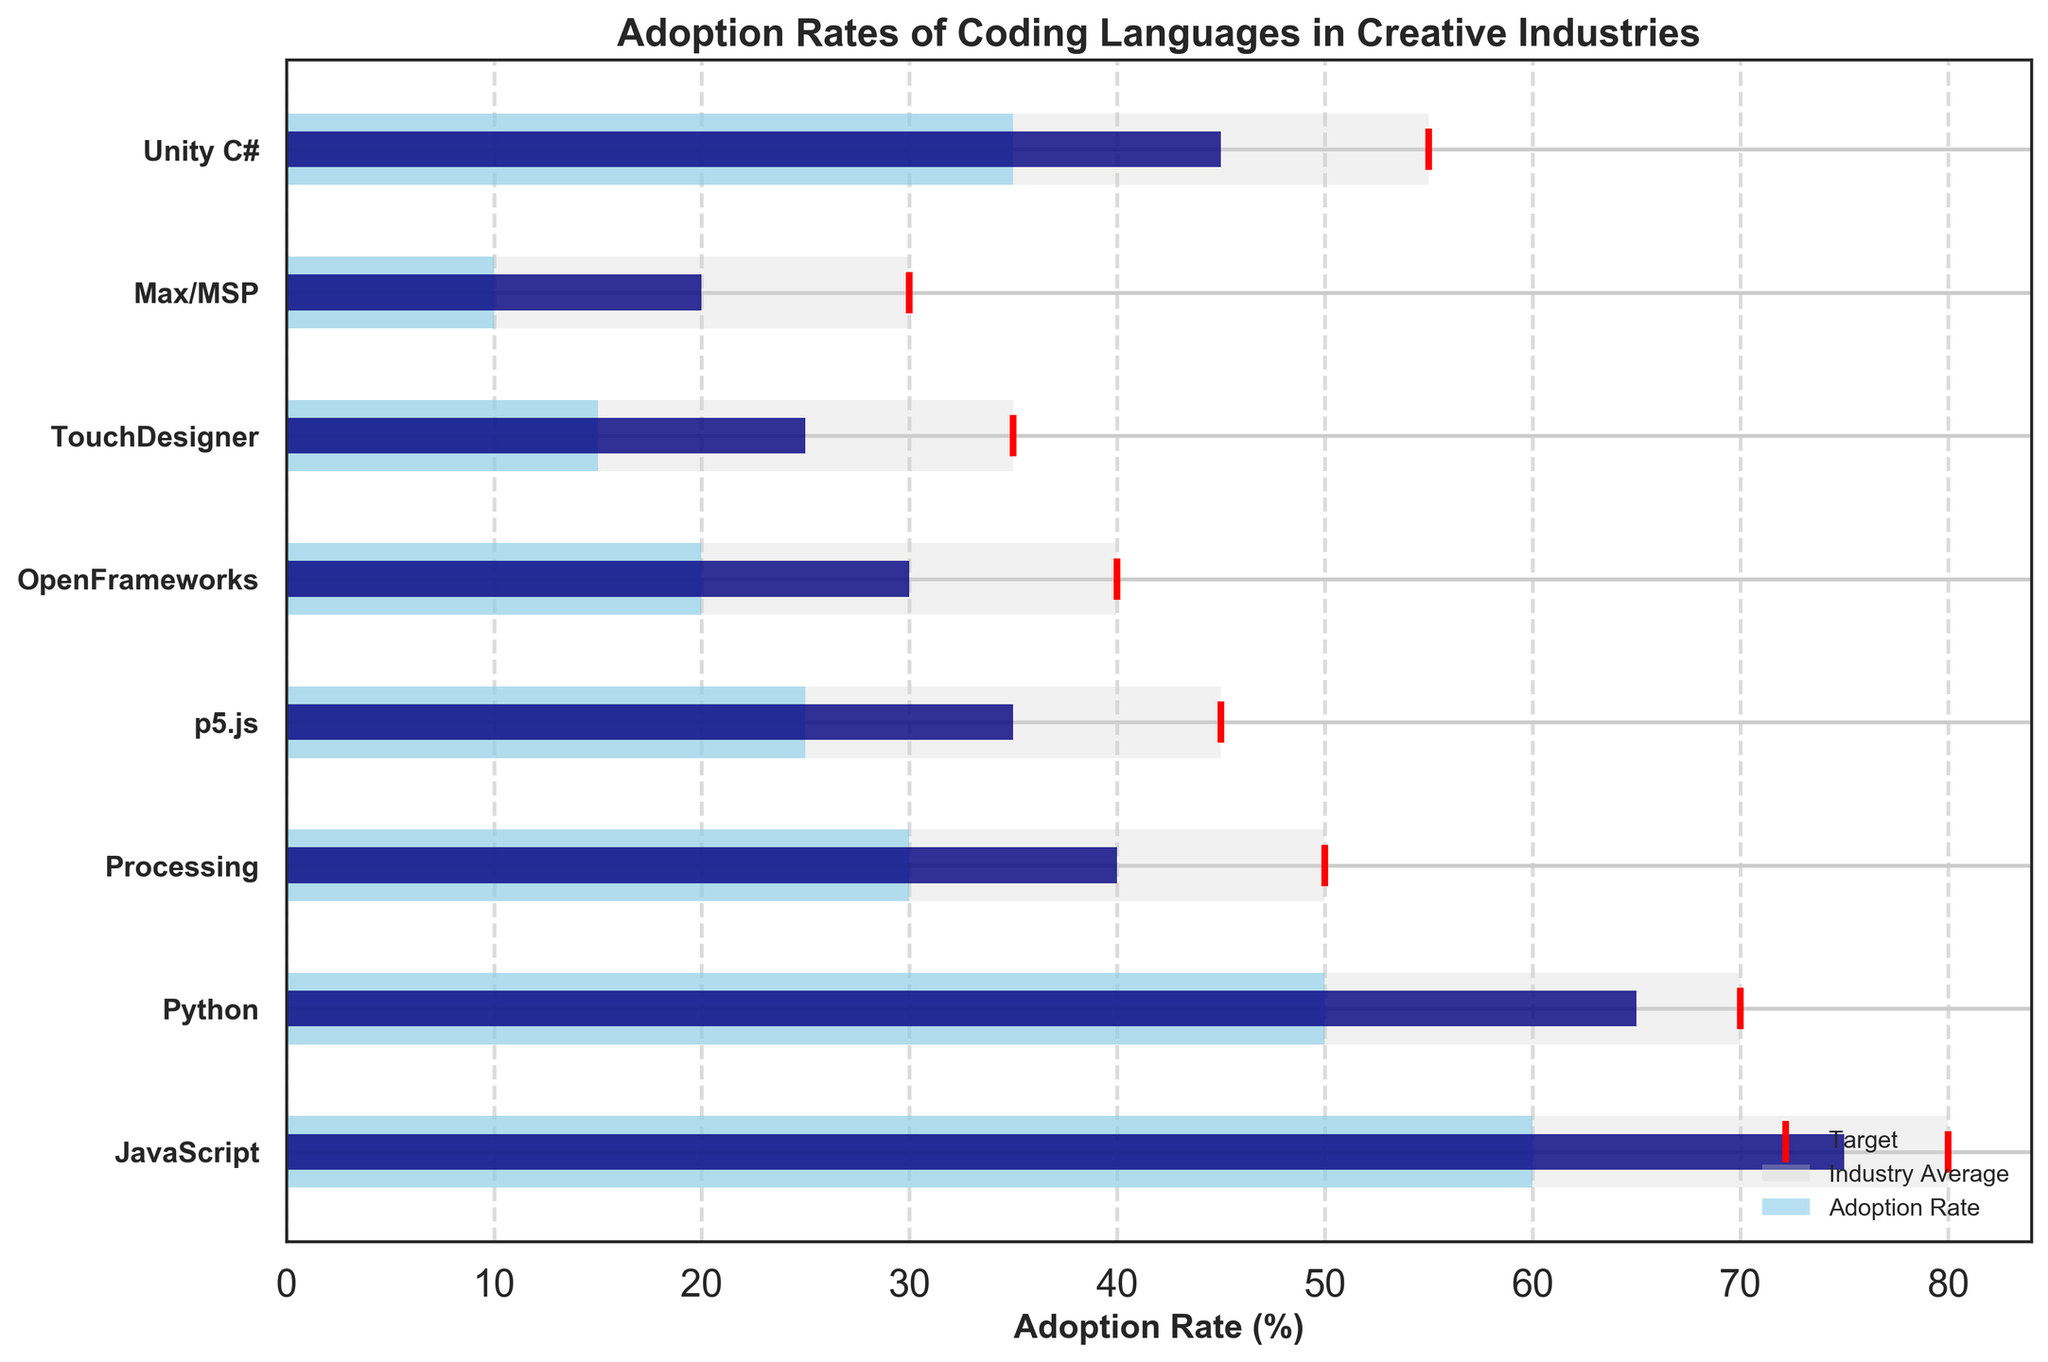What is the highest adoption rate among all coding languages? The highest adoption rate can be observed by looking at the largest value in the 'Adoption Rate' bars. The bar for JavaScript extends the farthest.
Answer: JavaScript with 75% Which language has the lowest target adoption rate? The target adoption rate is marked by red lines. The shortest red line corresponds to Max/MSP.
Answer: Max/MSP with 30% What is the difference between the adoption rate and the target for Python? Python's adoption rate is 65%, and its target is 70%. The difference is 70 - 65.
Answer: 5% How does the adoption rate of Unity C# compare to the industry average? For Unity C#, the adoption rate is 45%, and the industry average is 35%. By subtracting, 45 - 35, we get the difference.
Answer: 10% higher Which languages have an adoption rate exceeding their industry average by more than 10%? By comparing each language's adoption rate and industry average: JavaScript (75-60=15), Python (65-50=15), Unity C# (45-35=10), Processing (40-30=10). Only JavaScript and Python exceed by more than 10%.
Answer: JavaScript, Python How many languages have an adoption rate above 50%? By checking each adoption rate: JavaScript (75%), Python (65%), and none of the others exceed 50%, so there are 2 languages.
Answer: 2 What is the average industry average adoption rate across all languages? Sum the industry averages (60 + 50 + 30 + 25 + 20 + 15 + 10 + 35 = 245) and divide by the number of languages (8). 245 / 8 = 30.625.
Answer: 30.625% Which language has the smallest gap between its adoption rate and its target? Calculate gaps: JavaScript (80-75=5), Python (70-65=5), Processing (50-40=10), p5.js (45-35=10), OpenFrameworks (40-30=10), TouchDesigner (35-25=10), Max/MSP (30-20=10), Unity C# (55-45=10). JavaScript and Python have the smallest gap of 5%.
Answer: JavaScript, Python What is the median adoption rate of the listed languages? List the adoption rates (75, 65, 45, 40, 35, 30, 25, 20), sort them (20, 25, 30, 35, 40, 45, 65, 75), and find the middle values. Median is average of (35+40)=37.5%.
Answer: 37.5% By how much does the industry average for OpenFrameworks exceed that of Max/MSP? OpenFrameworks has an industry average of 20%, while Max/MSP has 10%. The difference is 20 - 10.
Answer: 10% 